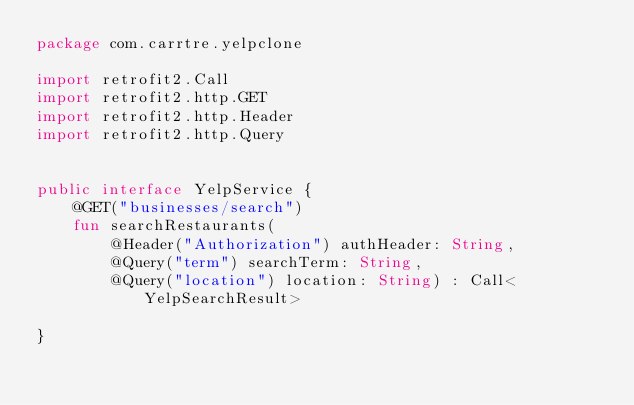Convert code to text. <code><loc_0><loc_0><loc_500><loc_500><_Kotlin_>package com.carrtre.yelpclone

import retrofit2.Call
import retrofit2.http.GET
import retrofit2.http.Header
import retrofit2.http.Query


public interface YelpService {
    @GET("businesses/search")
    fun searchRestaurants(
        @Header("Authorization") authHeader: String,
        @Query("term") searchTerm: String,
        @Query("location") location: String) : Call<YelpSearchResult>

}</code> 